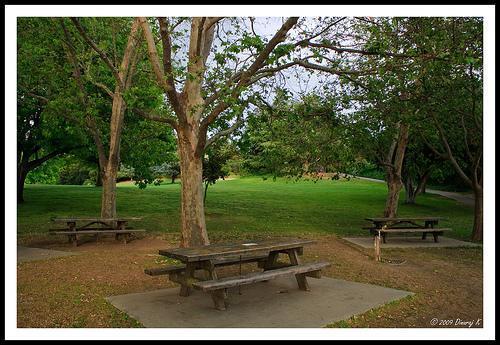How many tables are there?
Give a very brief answer. 3. How many tables are in the picture?
Give a very brief answer. 3. How many streets are in the picture?
Give a very brief answer. 1. 